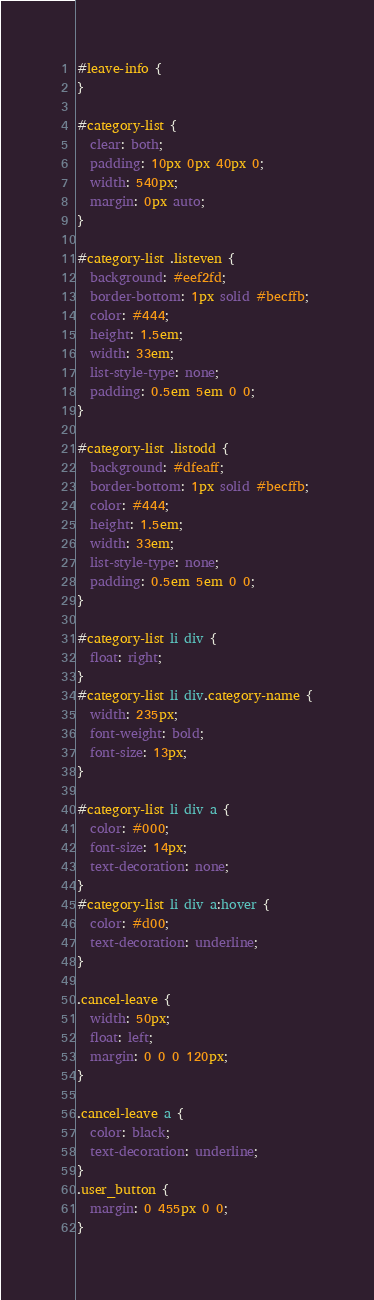Convert code to text. <code><loc_0><loc_0><loc_500><loc_500><_CSS_>#leave-info {
}

#category-list {
  clear: both;
  padding: 10px 0px 40px 0;
  width: 540px;
  margin: 0px auto;
}

#category-list .listeven {
  background: #eef2fd;
  border-bottom: 1px solid #becffb;
  color: #444;
  height: 1.5em;
  width: 33em;
  list-style-type: none;
  padding: 0.5em 5em 0 0;
}

#category-list .listodd {
  background: #dfeaff;
  border-bottom: 1px solid #becffb;
  color: #444;
  height: 1.5em;
  width: 33em;
  list-style-type: none;
  padding: 0.5em 5em 0 0;
}

#category-list li div {
  float: right;
}
#category-list li div.category-name {
  width: 235px;
  font-weight: bold;
  font-size: 13px;
}

#category-list li div a {
  color: #000;
  font-size: 14px;
  text-decoration: none;
}
#category-list li div a:hover {
  color: #d00;
  text-decoration: underline;
}

.cancel-leave {
  width: 50px;
  float: left;
  margin: 0 0 0 120px;
}

.cancel-leave a {
  color: black;
  text-decoration: underline;
}
.user_button {
  margin: 0 455px 0 0;
}
</code> 